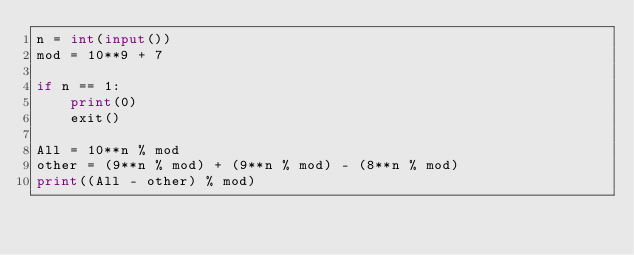<code> <loc_0><loc_0><loc_500><loc_500><_Python_>n = int(input())
mod = 10**9 + 7

if n == 1:
    print(0)
    exit()

All = 10**n % mod
other = (9**n % mod) + (9**n % mod) - (8**n % mod)
print((All - other) % mod)</code> 